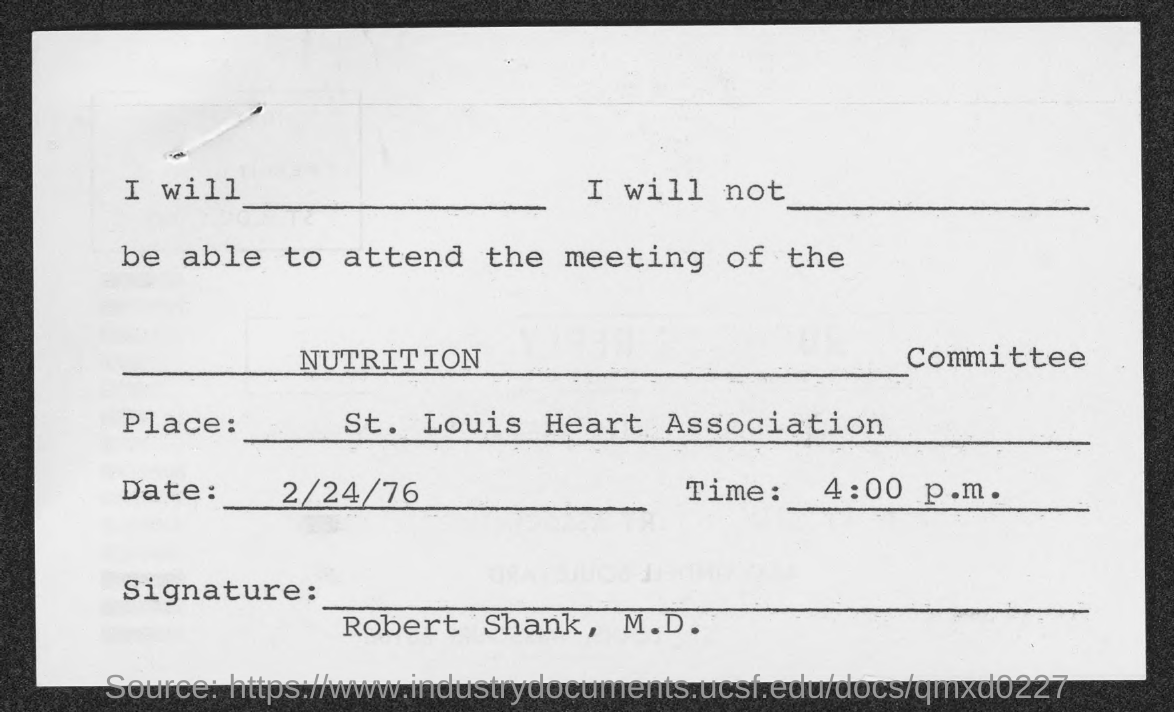Where is the Nutrition Committee meeting held?
Ensure brevity in your answer.  St. Louis Heart Association. What date is the Nutrition Committee meeting held?
Offer a very short reply. 2/24/76. What time is the Nutrition Committee meeting scheduled on 2/24/76?
Your answer should be compact. 4:00 p.m. Who has signed the document?
Your answer should be compact. Robert Shank, M.D. 